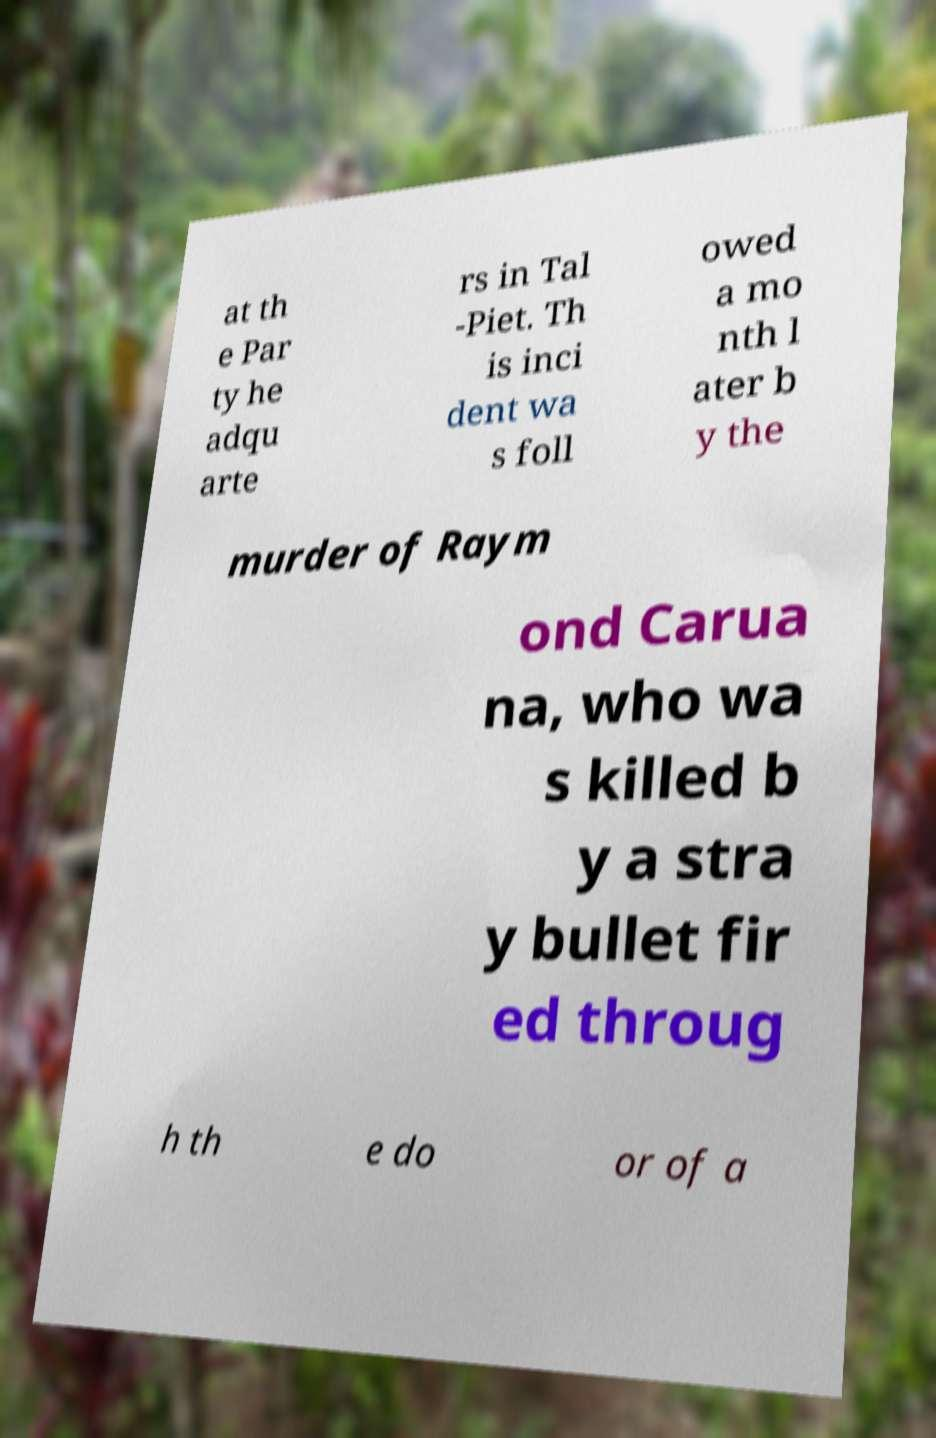Please identify and transcribe the text found in this image. at th e Par ty he adqu arte rs in Tal -Piet. Th is inci dent wa s foll owed a mo nth l ater b y the murder of Raym ond Carua na, who wa s killed b y a stra y bullet fir ed throug h th e do or of a 